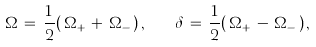<formula> <loc_0><loc_0><loc_500><loc_500>\Omega \, = \, \frac { 1 } { 2 } ( \, \Omega _ { + } \, + \, \Omega _ { - } \, ) \, , \quad \delta \, = \, \frac { 1 } { 2 } ( \, \Omega _ { + } \, - \, \Omega _ { - } \, ) \, ,</formula> 